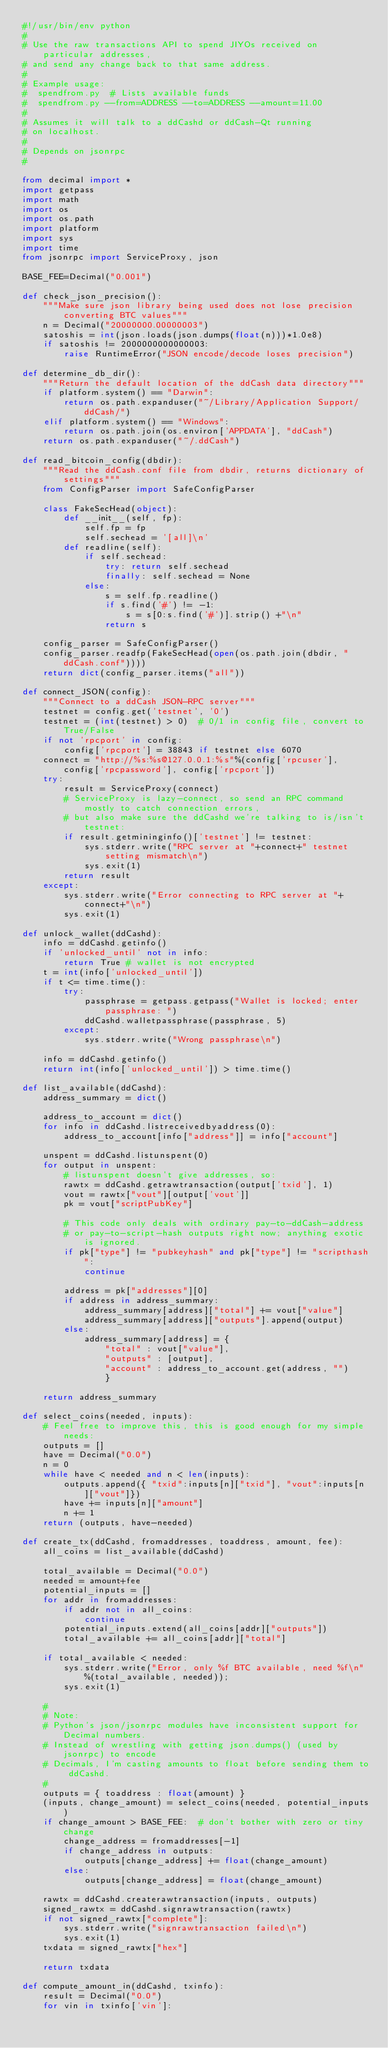Convert code to text. <code><loc_0><loc_0><loc_500><loc_500><_Python_>#!/usr/bin/env python
#
# Use the raw transactions API to spend JIYOs received on particular addresses,
# and send any change back to that same address.
#
# Example usage:
#  spendfrom.py  # Lists available funds
#  spendfrom.py --from=ADDRESS --to=ADDRESS --amount=11.00
#
# Assumes it will talk to a ddCashd or ddCash-Qt running
# on localhost.
#
# Depends on jsonrpc
#

from decimal import *
import getpass
import math
import os
import os.path
import platform
import sys
import time
from jsonrpc import ServiceProxy, json

BASE_FEE=Decimal("0.001")

def check_json_precision():
    """Make sure json library being used does not lose precision converting BTC values"""
    n = Decimal("20000000.00000003")
    satoshis = int(json.loads(json.dumps(float(n)))*1.0e8)
    if satoshis != 2000000000000003:
        raise RuntimeError("JSON encode/decode loses precision")

def determine_db_dir():
    """Return the default location of the ddCash data directory"""
    if platform.system() == "Darwin":
        return os.path.expanduser("~/Library/Application Support/ddCash/")
    elif platform.system() == "Windows":
        return os.path.join(os.environ['APPDATA'], "ddCash")
    return os.path.expanduser("~/.ddCash")

def read_bitcoin_config(dbdir):
    """Read the ddCash.conf file from dbdir, returns dictionary of settings"""
    from ConfigParser import SafeConfigParser

    class FakeSecHead(object):
        def __init__(self, fp):
            self.fp = fp
            self.sechead = '[all]\n'
        def readline(self):
            if self.sechead:
                try: return self.sechead
                finally: self.sechead = None
            else:
                s = self.fp.readline()
                if s.find('#') != -1:
                    s = s[0:s.find('#')].strip() +"\n"
                return s

    config_parser = SafeConfigParser()
    config_parser.readfp(FakeSecHead(open(os.path.join(dbdir, "ddCash.conf"))))
    return dict(config_parser.items("all"))

def connect_JSON(config):
    """Connect to a ddCash JSON-RPC server"""
    testnet = config.get('testnet', '0')
    testnet = (int(testnet) > 0)  # 0/1 in config file, convert to True/False
    if not 'rpcport' in config:
        config['rpcport'] = 38843 if testnet else 6070
    connect = "http://%s:%s@127.0.0.1:%s"%(config['rpcuser'], config['rpcpassword'], config['rpcport'])
    try:
        result = ServiceProxy(connect)
        # ServiceProxy is lazy-connect, so send an RPC command mostly to catch connection errors,
        # but also make sure the ddCashd we're talking to is/isn't testnet:
        if result.getmininginfo()['testnet'] != testnet:
            sys.stderr.write("RPC server at "+connect+" testnet setting mismatch\n")
            sys.exit(1)
        return result
    except:
        sys.stderr.write("Error connecting to RPC server at "+connect+"\n")
        sys.exit(1)

def unlock_wallet(ddCashd):
    info = ddCashd.getinfo()
    if 'unlocked_until' not in info:
        return True # wallet is not encrypted
    t = int(info['unlocked_until'])
    if t <= time.time():
        try:
            passphrase = getpass.getpass("Wallet is locked; enter passphrase: ")
            ddCashd.walletpassphrase(passphrase, 5)
        except:
            sys.stderr.write("Wrong passphrase\n")

    info = ddCashd.getinfo()
    return int(info['unlocked_until']) > time.time()

def list_available(ddCashd):
    address_summary = dict()

    address_to_account = dict()
    for info in ddCashd.listreceivedbyaddress(0):
        address_to_account[info["address"]] = info["account"]

    unspent = ddCashd.listunspent(0)
    for output in unspent:
        # listunspent doesn't give addresses, so:
        rawtx = ddCashd.getrawtransaction(output['txid'], 1)
        vout = rawtx["vout"][output['vout']]
        pk = vout["scriptPubKey"]

        # This code only deals with ordinary pay-to-ddCash-address
        # or pay-to-script-hash outputs right now; anything exotic is ignored.
        if pk["type"] != "pubkeyhash" and pk["type"] != "scripthash":
            continue

        address = pk["addresses"][0]
        if address in address_summary:
            address_summary[address]["total"] += vout["value"]
            address_summary[address]["outputs"].append(output)
        else:
            address_summary[address] = {
                "total" : vout["value"],
                "outputs" : [output],
                "account" : address_to_account.get(address, "")
                }

    return address_summary

def select_coins(needed, inputs):
    # Feel free to improve this, this is good enough for my simple needs:
    outputs = []
    have = Decimal("0.0")
    n = 0
    while have < needed and n < len(inputs):
        outputs.append({ "txid":inputs[n]["txid"], "vout":inputs[n]["vout"]})
        have += inputs[n]["amount"]
        n += 1
    return (outputs, have-needed)

def create_tx(ddCashd, fromaddresses, toaddress, amount, fee):
    all_coins = list_available(ddCashd)

    total_available = Decimal("0.0")
    needed = amount+fee
    potential_inputs = []
    for addr in fromaddresses:
        if addr not in all_coins:
            continue
        potential_inputs.extend(all_coins[addr]["outputs"])
        total_available += all_coins[addr]["total"]

    if total_available < needed:
        sys.stderr.write("Error, only %f BTC available, need %f\n"%(total_available, needed));
        sys.exit(1)

    #
    # Note:
    # Python's json/jsonrpc modules have inconsistent support for Decimal numbers.
    # Instead of wrestling with getting json.dumps() (used by jsonrpc) to encode
    # Decimals, I'm casting amounts to float before sending them to ddCashd.
    #
    outputs = { toaddress : float(amount) }
    (inputs, change_amount) = select_coins(needed, potential_inputs)
    if change_amount > BASE_FEE:  # don't bother with zero or tiny change
        change_address = fromaddresses[-1]
        if change_address in outputs:
            outputs[change_address] += float(change_amount)
        else:
            outputs[change_address] = float(change_amount)

    rawtx = ddCashd.createrawtransaction(inputs, outputs)
    signed_rawtx = ddCashd.signrawtransaction(rawtx)
    if not signed_rawtx["complete"]:
        sys.stderr.write("signrawtransaction failed\n")
        sys.exit(1)
    txdata = signed_rawtx["hex"]

    return txdata

def compute_amount_in(ddCashd, txinfo):
    result = Decimal("0.0")
    for vin in txinfo['vin']:</code> 